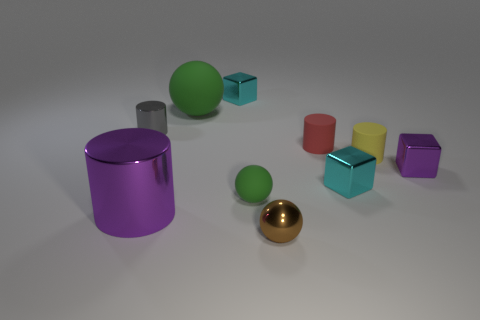What shape is the tiny shiny thing that is behind the small yellow rubber cylinder and to the right of the gray metallic thing?
Your answer should be compact. Cube. What size is the green matte object that is in front of the gray metallic cylinder?
Offer a terse response. Small. There is a sphere behind the tiny gray metal thing; is it the same color as the small metal cylinder?
Keep it short and to the point. No. How many other large rubber things are the same shape as the large purple object?
Offer a terse response. 0. How many things are either cyan objects in front of the gray cylinder or cyan things that are in front of the gray thing?
Give a very brief answer. 1. What number of purple objects are either big shiny objects or small cylinders?
Your answer should be compact. 1. What is the material of the small cylinder that is behind the yellow cylinder and right of the large cylinder?
Your answer should be compact. Rubber. Does the small yellow object have the same material as the small red object?
Make the answer very short. Yes. How many blue metallic cubes are the same size as the gray metal cylinder?
Ensure brevity in your answer.  0. Are there the same number of large objects that are in front of the small brown metallic object and tiny metal objects?
Keep it short and to the point. No. 